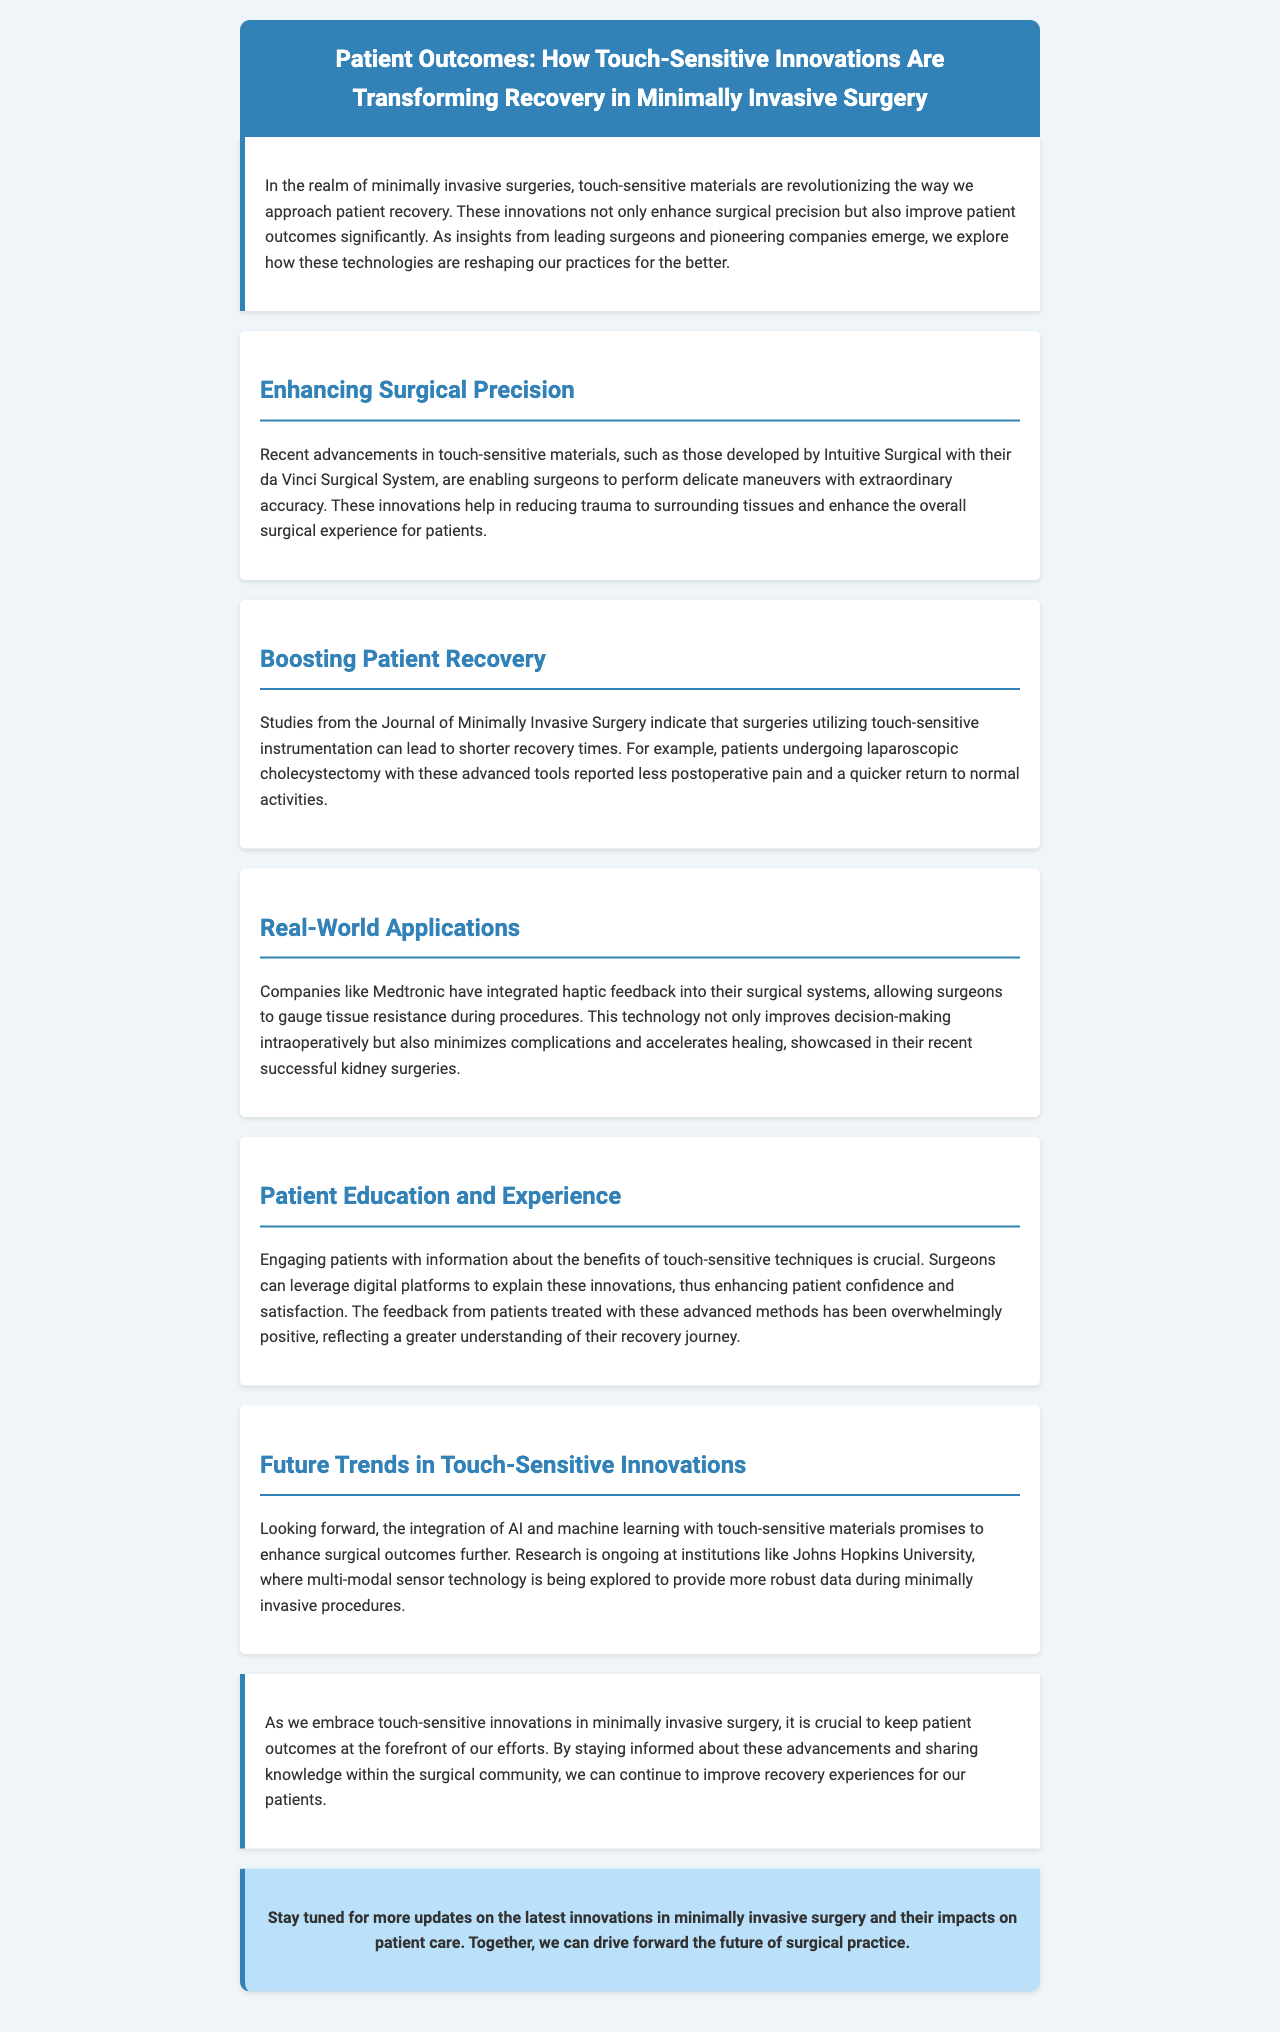What is the main focus of the newsletter? The newsletter discusses touch-sensitive innovations transforming recovery in minimally invasive surgery.
Answer: Touch-sensitive innovations Which company developed the da Vinci Surgical System? The document mentions Intuitive Surgical as the developer of the da Vinci Surgical System.
Answer: Intuitive Surgical What type of surgery was mentioned to report less postoperative pain? The newsletter refers to laparoscopic cholecystectomy as having reported less postoperative pain with touch-sensitive instrumentation.
Answer: Laparoscopic cholecystectomy What technology does Medtronic integrate into their surgical systems? The document states that Medtronic integrates haptic feedback into their surgical systems.
Answer: Haptic feedback What is one benefit of engaging patients with information about touch-sensitive techniques? The newsletter highlights that engaging patients enhances their confidence and satisfaction regarding their recovery.
Answer: Confidence and satisfaction What future technology is mentioned that promises enhancements in surgical outcomes? The document refers to AI and machine learning as future technologies that will enhance surgical outcomes.
Answer: AI and machine learning How does the document suggest sharing knowledge within the surgical community? It suggests that staying informed about advancements and sharing knowledge can improve patient recovery experiences.
Answer: Sharing knowledge What is the conclusion regarding patient outcomes? The conclusion emphasizes the importance of keeping patient outcomes at the forefront as innovations are embraced.
Answer: Patient outcomes at the forefront 